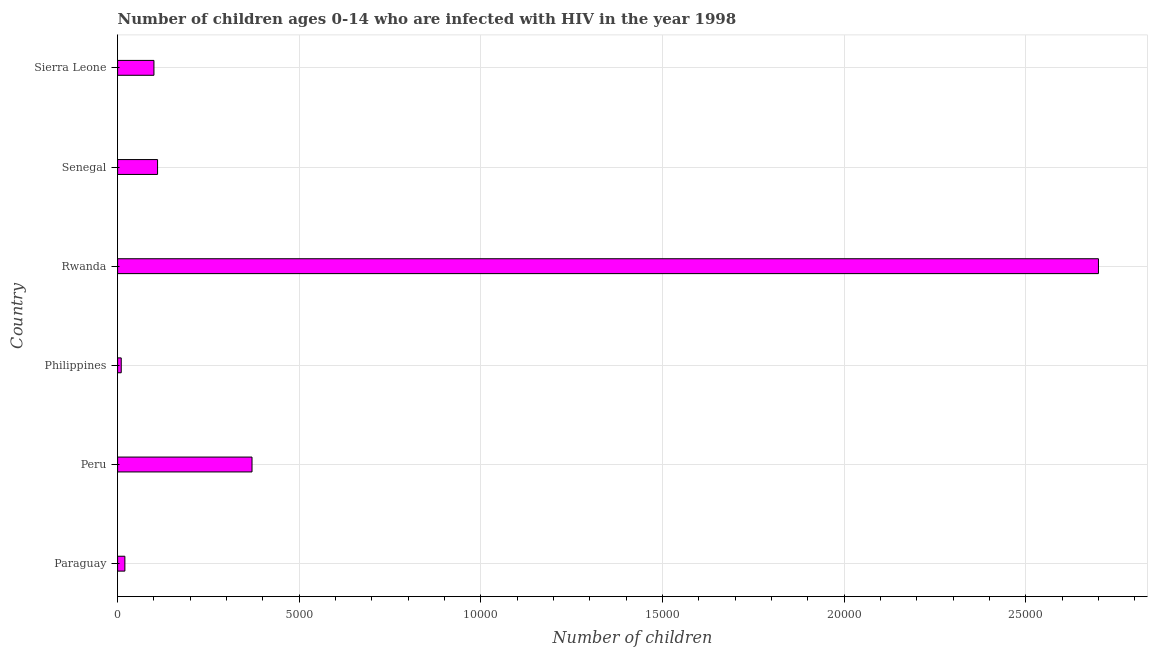Does the graph contain any zero values?
Ensure brevity in your answer.  No. Does the graph contain grids?
Give a very brief answer. Yes. What is the title of the graph?
Give a very brief answer. Number of children ages 0-14 who are infected with HIV in the year 1998. What is the label or title of the X-axis?
Your answer should be compact. Number of children. What is the number of children living with hiv in Sierra Leone?
Offer a terse response. 1000. Across all countries, what is the maximum number of children living with hiv?
Keep it short and to the point. 2.70e+04. Across all countries, what is the minimum number of children living with hiv?
Ensure brevity in your answer.  100. In which country was the number of children living with hiv maximum?
Offer a terse response. Rwanda. In which country was the number of children living with hiv minimum?
Offer a terse response. Philippines. What is the sum of the number of children living with hiv?
Provide a short and direct response. 3.31e+04. What is the difference between the number of children living with hiv in Paraguay and Sierra Leone?
Keep it short and to the point. -800. What is the average number of children living with hiv per country?
Your response must be concise. 5516. What is the median number of children living with hiv?
Offer a terse response. 1050. In how many countries, is the number of children living with hiv greater than 26000 ?
Offer a terse response. 1. What is the ratio of the number of children living with hiv in Paraguay to that in Rwanda?
Make the answer very short. 0.01. Is the number of children living with hiv in Paraguay less than that in Philippines?
Provide a short and direct response. No. Is the difference between the number of children living with hiv in Paraguay and Philippines greater than the difference between any two countries?
Offer a terse response. No. What is the difference between the highest and the second highest number of children living with hiv?
Offer a very short reply. 2.33e+04. Is the sum of the number of children living with hiv in Paraguay and Sierra Leone greater than the maximum number of children living with hiv across all countries?
Give a very brief answer. No. What is the difference between the highest and the lowest number of children living with hiv?
Provide a succinct answer. 2.69e+04. In how many countries, is the number of children living with hiv greater than the average number of children living with hiv taken over all countries?
Provide a short and direct response. 1. Are all the bars in the graph horizontal?
Give a very brief answer. Yes. What is the difference between two consecutive major ticks on the X-axis?
Provide a succinct answer. 5000. What is the Number of children of Paraguay?
Make the answer very short. 200. What is the Number of children of Peru?
Provide a succinct answer. 3700. What is the Number of children in Rwanda?
Provide a succinct answer. 2.70e+04. What is the Number of children in Senegal?
Provide a succinct answer. 1100. What is the Number of children in Sierra Leone?
Make the answer very short. 1000. What is the difference between the Number of children in Paraguay and Peru?
Offer a very short reply. -3500. What is the difference between the Number of children in Paraguay and Rwanda?
Give a very brief answer. -2.68e+04. What is the difference between the Number of children in Paraguay and Senegal?
Make the answer very short. -900. What is the difference between the Number of children in Paraguay and Sierra Leone?
Your answer should be very brief. -800. What is the difference between the Number of children in Peru and Philippines?
Make the answer very short. 3600. What is the difference between the Number of children in Peru and Rwanda?
Make the answer very short. -2.33e+04. What is the difference between the Number of children in Peru and Senegal?
Ensure brevity in your answer.  2600. What is the difference between the Number of children in Peru and Sierra Leone?
Provide a succinct answer. 2700. What is the difference between the Number of children in Philippines and Rwanda?
Keep it short and to the point. -2.69e+04. What is the difference between the Number of children in Philippines and Senegal?
Your answer should be very brief. -1000. What is the difference between the Number of children in Philippines and Sierra Leone?
Keep it short and to the point. -900. What is the difference between the Number of children in Rwanda and Senegal?
Make the answer very short. 2.59e+04. What is the difference between the Number of children in Rwanda and Sierra Leone?
Provide a short and direct response. 2.60e+04. What is the ratio of the Number of children in Paraguay to that in Peru?
Your answer should be compact. 0.05. What is the ratio of the Number of children in Paraguay to that in Rwanda?
Ensure brevity in your answer.  0.01. What is the ratio of the Number of children in Paraguay to that in Senegal?
Ensure brevity in your answer.  0.18. What is the ratio of the Number of children in Paraguay to that in Sierra Leone?
Make the answer very short. 0.2. What is the ratio of the Number of children in Peru to that in Rwanda?
Ensure brevity in your answer.  0.14. What is the ratio of the Number of children in Peru to that in Senegal?
Make the answer very short. 3.36. What is the ratio of the Number of children in Peru to that in Sierra Leone?
Your answer should be very brief. 3.7. What is the ratio of the Number of children in Philippines to that in Rwanda?
Give a very brief answer. 0. What is the ratio of the Number of children in Philippines to that in Senegal?
Offer a terse response. 0.09. What is the ratio of the Number of children in Philippines to that in Sierra Leone?
Offer a terse response. 0.1. What is the ratio of the Number of children in Rwanda to that in Senegal?
Your answer should be very brief. 24.55. What is the ratio of the Number of children in Senegal to that in Sierra Leone?
Provide a short and direct response. 1.1. 